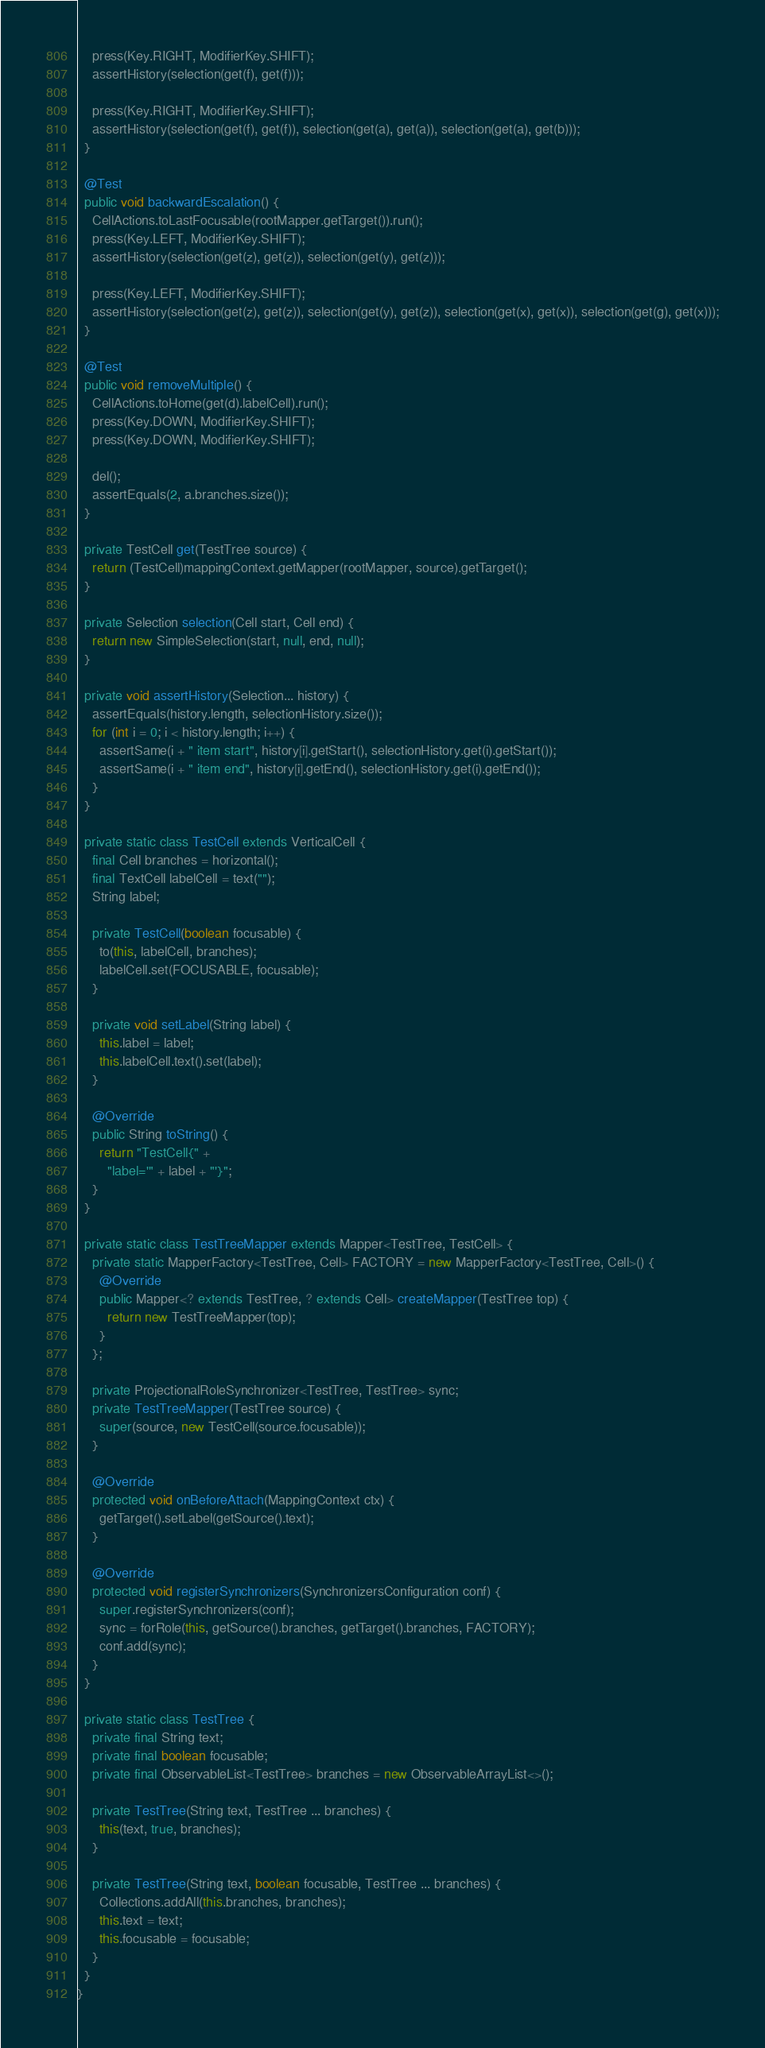Convert code to text. <code><loc_0><loc_0><loc_500><loc_500><_Java_>    press(Key.RIGHT, ModifierKey.SHIFT);
    assertHistory(selection(get(f), get(f)));

    press(Key.RIGHT, ModifierKey.SHIFT);
    assertHistory(selection(get(f), get(f)), selection(get(a), get(a)), selection(get(a), get(b)));
  }

  @Test
  public void backwardEscalation() {
    CellActions.toLastFocusable(rootMapper.getTarget()).run();
    press(Key.LEFT, ModifierKey.SHIFT);
    assertHistory(selection(get(z), get(z)), selection(get(y), get(z)));

    press(Key.LEFT, ModifierKey.SHIFT);
    assertHistory(selection(get(z), get(z)), selection(get(y), get(z)), selection(get(x), get(x)), selection(get(g), get(x)));
  }

  @Test
  public void removeMultiple() {
    CellActions.toHome(get(d).labelCell).run();
    press(Key.DOWN, ModifierKey.SHIFT);
    press(Key.DOWN, ModifierKey.SHIFT);

    del();
    assertEquals(2, a.branches.size());
  }

  private TestCell get(TestTree source) {
    return (TestCell)mappingContext.getMapper(rootMapper, source).getTarget();
  }

  private Selection selection(Cell start, Cell end) {
    return new SimpleSelection(start, null, end, null);
  }

  private void assertHistory(Selection... history) {
    assertEquals(history.length, selectionHistory.size());
    for (int i = 0; i < history.length; i++) {
      assertSame(i + " item start", history[i].getStart(), selectionHistory.get(i).getStart());
      assertSame(i + " item end", history[i].getEnd(), selectionHistory.get(i).getEnd());
    }
  }

  private static class TestCell extends VerticalCell {
    final Cell branches = horizontal();
    final TextCell labelCell = text("");
    String label;

    private TestCell(boolean focusable) {
      to(this, labelCell, branches);
      labelCell.set(FOCUSABLE, focusable);
    }

    private void setLabel(String label) {
      this.label = label;
      this.labelCell.text().set(label);
    }

    @Override
    public String toString() {
      return "TestCell{" +
        "label='" + label + "'}";
    }
  }

  private static class TestTreeMapper extends Mapper<TestTree, TestCell> {
    private static MapperFactory<TestTree, Cell> FACTORY = new MapperFactory<TestTree, Cell>() {
      @Override
      public Mapper<? extends TestTree, ? extends Cell> createMapper(TestTree top) {
        return new TestTreeMapper(top);
      }
    };

    private ProjectionalRoleSynchronizer<TestTree, TestTree> sync;
    private TestTreeMapper(TestTree source) {
      super(source, new TestCell(source.focusable));
    }

    @Override
    protected void onBeforeAttach(MappingContext ctx) {
      getTarget().setLabel(getSource().text);
    }

    @Override
    protected void registerSynchronizers(SynchronizersConfiguration conf) {
      super.registerSynchronizers(conf);
      sync = forRole(this, getSource().branches, getTarget().branches, FACTORY);
      conf.add(sync);
    }
  }

  private static class TestTree {
    private final String text;
    private final boolean focusable;
    private final ObservableList<TestTree> branches = new ObservableArrayList<>();

    private TestTree(String text, TestTree ... branches) {
      this(text, true, branches);
    }

    private TestTree(String text, boolean focusable, TestTree ... branches) {
      Collections.addAll(this.branches, branches);
      this.text = text;
      this.focusable = focusable;
    }
  }
}
</code> 